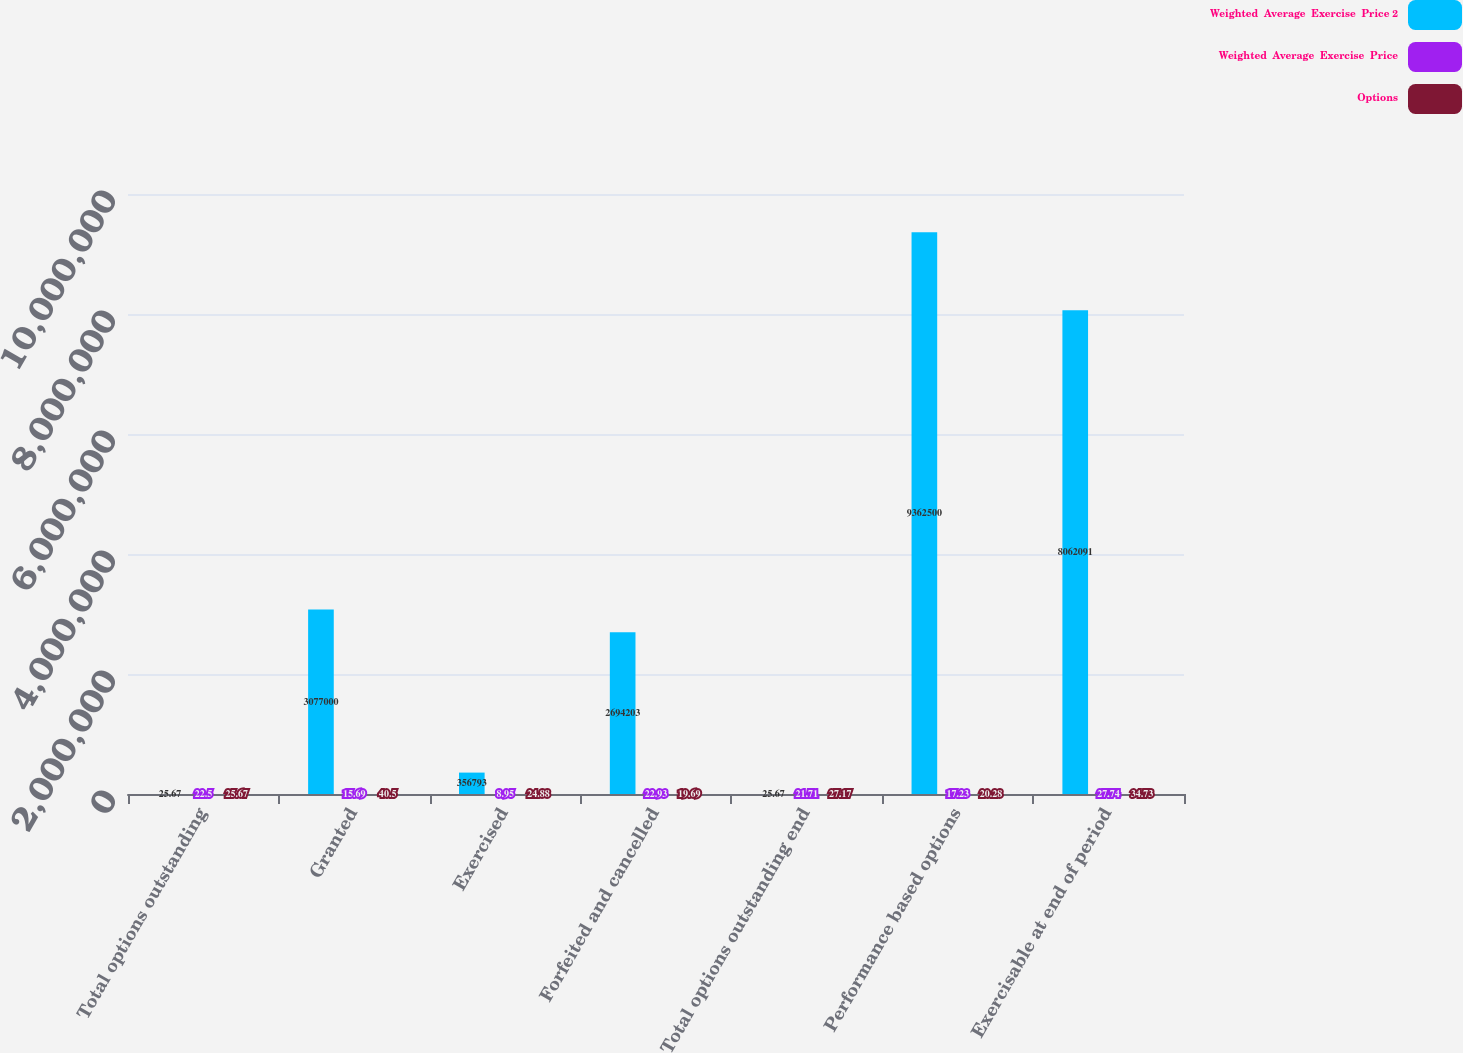<chart> <loc_0><loc_0><loc_500><loc_500><stacked_bar_chart><ecel><fcel>Total options outstanding<fcel>Granted<fcel>Exercised<fcel>Forfeited and cancelled<fcel>Total options outstanding end<fcel>Performance based options<fcel>Exercisable at end of period<nl><fcel>Weighted  Average  Exercise  Price 2<fcel>25.67<fcel>3.077e+06<fcel>356793<fcel>2.6942e+06<fcel>25.67<fcel>9.3625e+06<fcel>8.06209e+06<nl><fcel>Weighted  Average  Exercise  Price<fcel>22.5<fcel>15.69<fcel>8.95<fcel>22.93<fcel>21.71<fcel>17.23<fcel>27.74<nl><fcel>Options<fcel>25.67<fcel>40.5<fcel>24.88<fcel>19.69<fcel>27.17<fcel>20.28<fcel>34.73<nl></chart> 